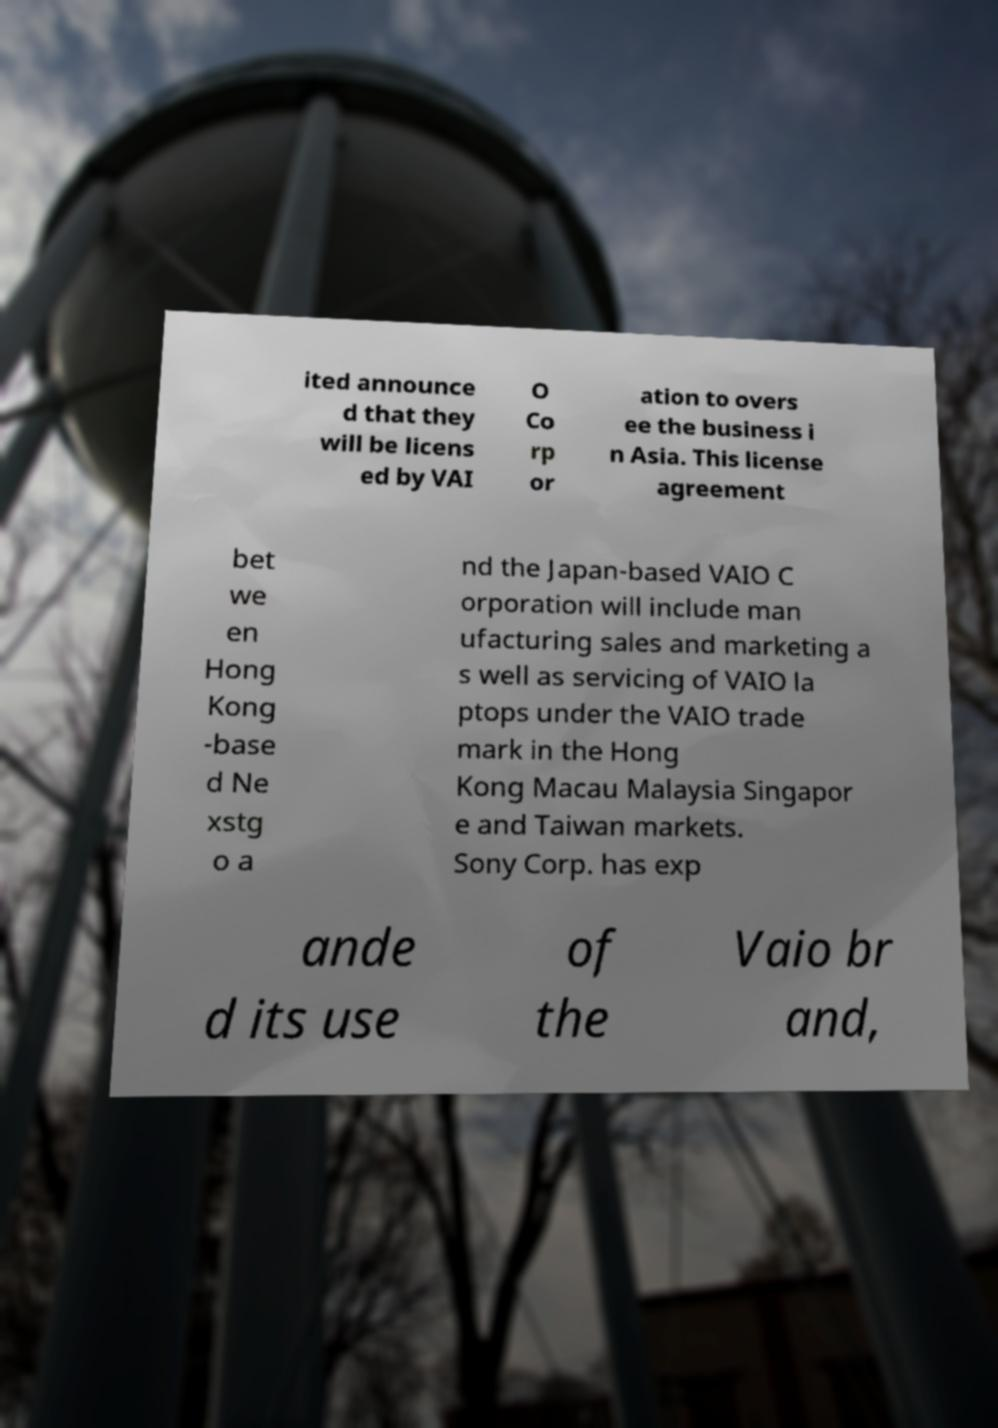What messages or text are displayed in this image? I need them in a readable, typed format. ited announce d that they will be licens ed by VAI O Co rp or ation to overs ee the business i n Asia. This license agreement bet we en Hong Kong -base d Ne xstg o a nd the Japan-based VAIO C orporation will include man ufacturing sales and marketing a s well as servicing of VAIO la ptops under the VAIO trade mark in the Hong Kong Macau Malaysia Singapor e and Taiwan markets. Sony Corp. has exp ande d its use of the Vaio br and, 